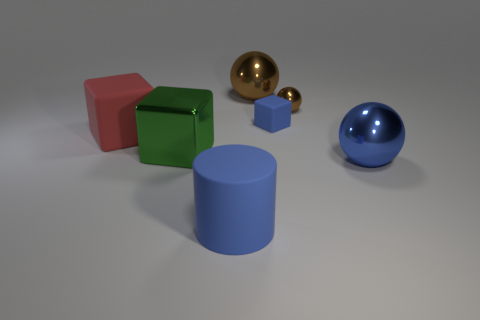Is the color of the small cube the same as the object that is right of the small brown object?
Offer a very short reply. Yes. There is a metallic object to the left of the brown metallic sphere that is to the left of the blue rubber object that is behind the blue rubber cylinder; what is its color?
Keep it short and to the point. Green. Does the red object have the same material as the big green cube?
Provide a short and direct response. No. Is there a red rubber cube of the same size as the blue rubber cylinder?
Ensure brevity in your answer.  Yes. There is a cylinder that is the same size as the red matte thing; what is its material?
Your answer should be very brief. Rubber. Is there a large object that has the same shape as the tiny blue rubber object?
Your answer should be compact. Yes. What material is the large ball that is the same color as the small rubber object?
Give a very brief answer. Metal. What is the shape of the blue thing that is left of the small matte cube?
Ensure brevity in your answer.  Cylinder. What number of big yellow things are there?
Ensure brevity in your answer.  0. What is the color of the big block that is made of the same material as the tiny cube?
Offer a terse response. Red. 